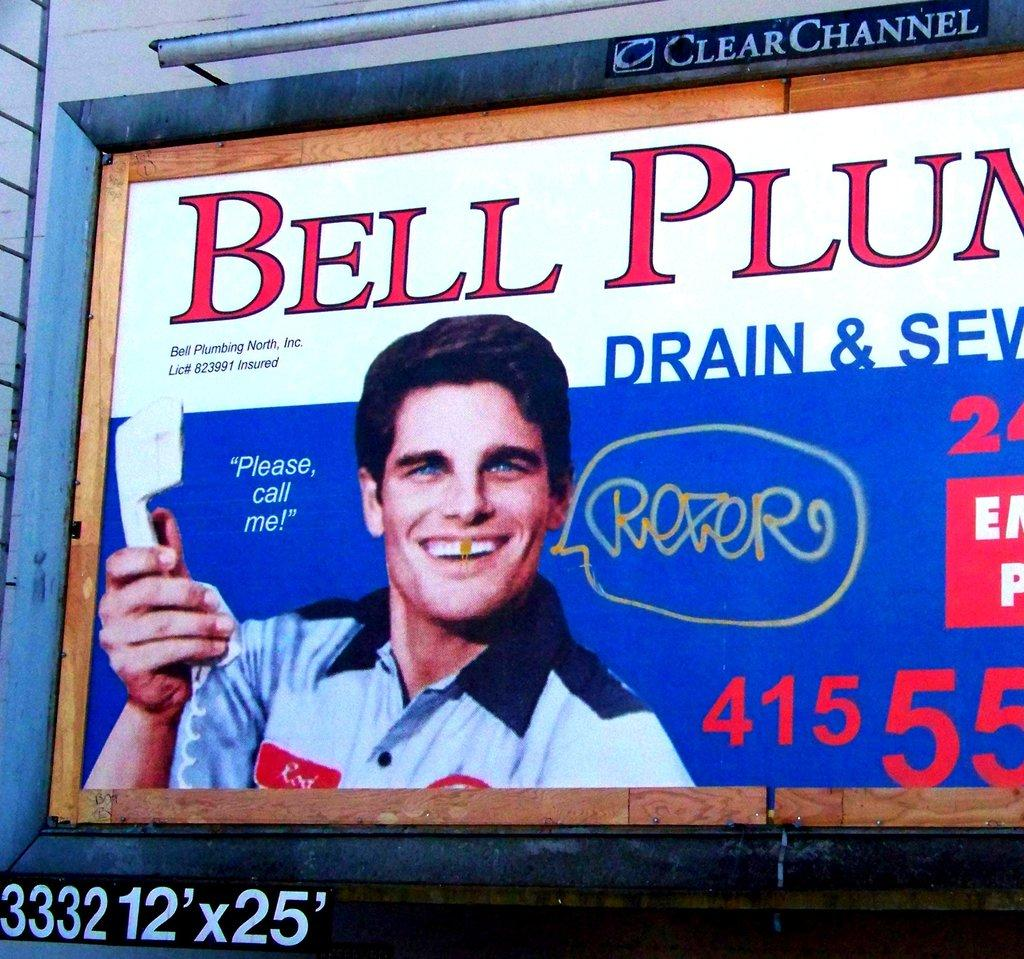<image>
Describe the image concisely. Someone used graffiti on the Bell Plumbing ad. 